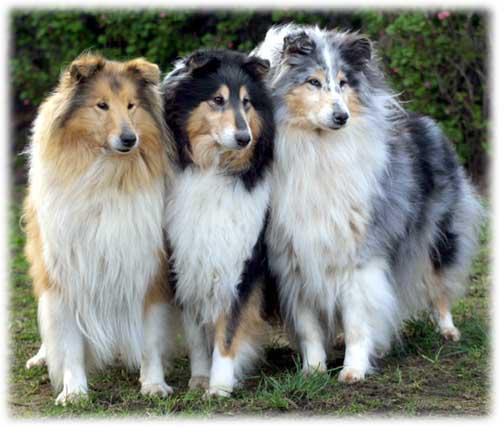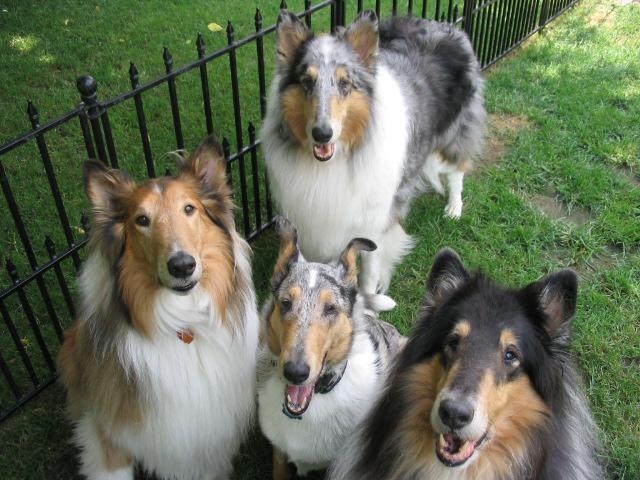The first image is the image on the left, the second image is the image on the right. Analyze the images presented: Is the assertion "There are 4 dogs total" valid? Answer yes or no. No. The first image is the image on the left, the second image is the image on the right. Examine the images to the left and right. Is the description "One image depicts exactly three collies standing in a row, each with a different fur coloring pattern." accurate? Answer yes or no. Yes. 